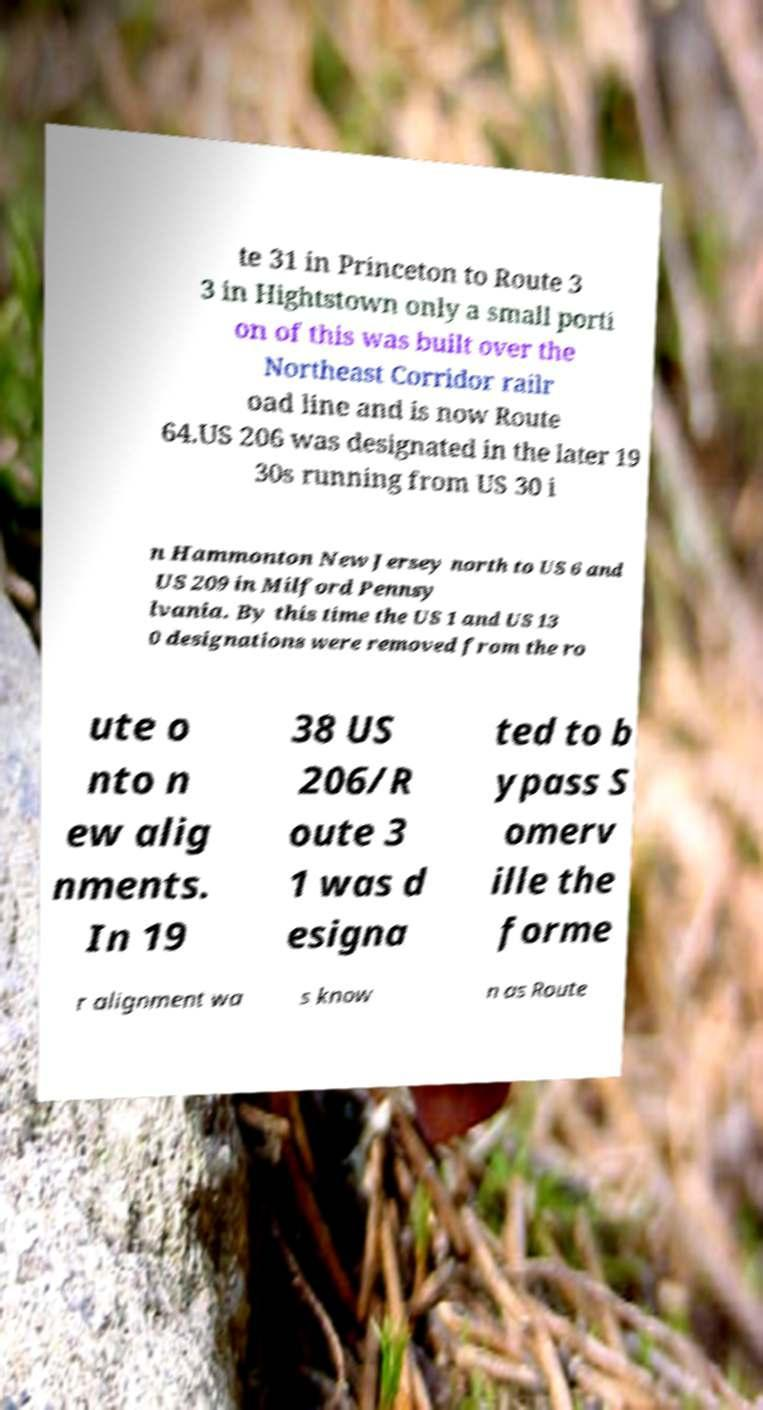Could you extract and type out the text from this image? te 31 in Princeton to Route 3 3 in Hightstown only a small porti on of this was built over the Northeast Corridor railr oad line and is now Route 64.US 206 was designated in the later 19 30s running from US 30 i n Hammonton New Jersey north to US 6 and US 209 in Milford Pennsy lvania. By this time the US 1 and US 13 0 designations were removed from the ro ute o nto n ew alig nments. In 19 38 US 206/R oute 3 1 was d esigna ted to b ypass S omerv ille the forme r alignment wa s know n as Route 